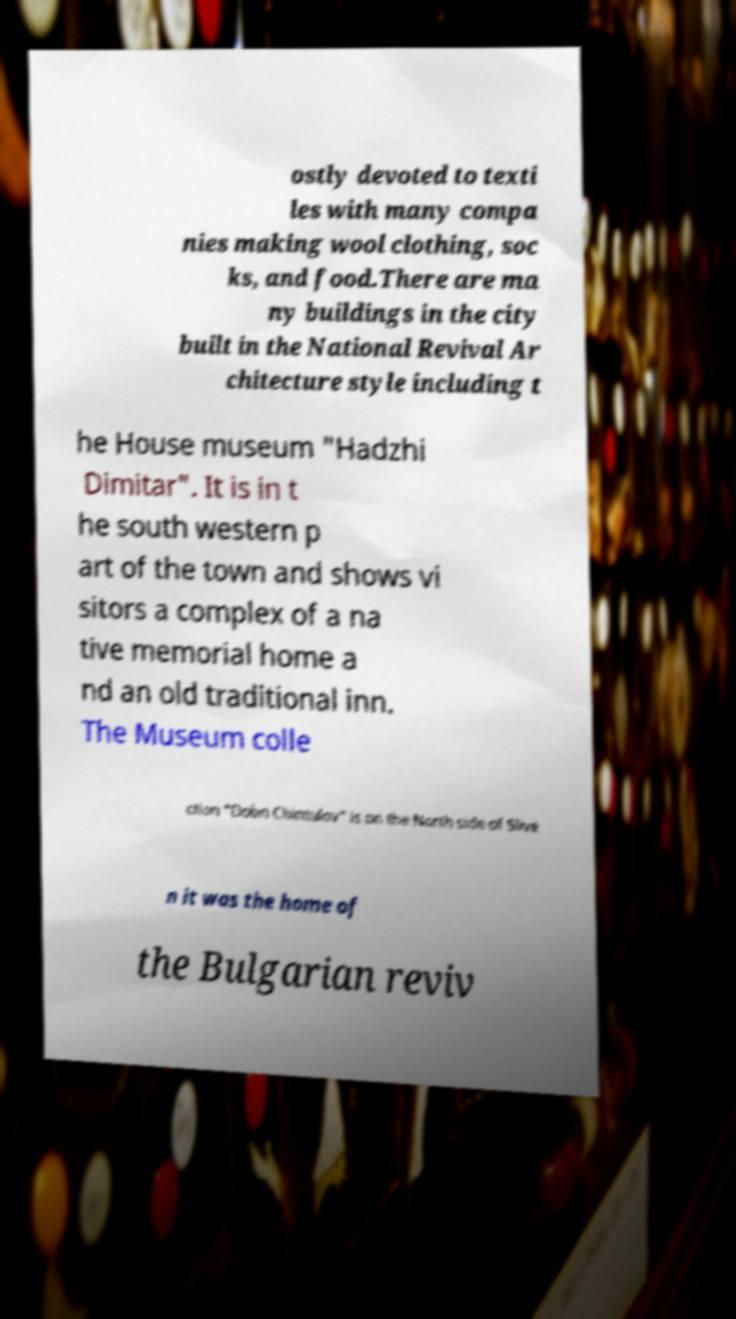Could you extract and type out the text from this image? ostly devoted to texti les with many compa nies making wool clothing, soc ks, and food.There are ma ny buildings in the city built in the National Revival Ar chitecture style including t he House museum "Hadzhi Dimitar". It is in t he south western p art of the town and shows vi sitors a complex of a na tive memorial home a nd an old traditional inn. The Museum colle ction "Dobri Chintulov" is on the North side of Slive n it was the home of the Bulgarian reviv 